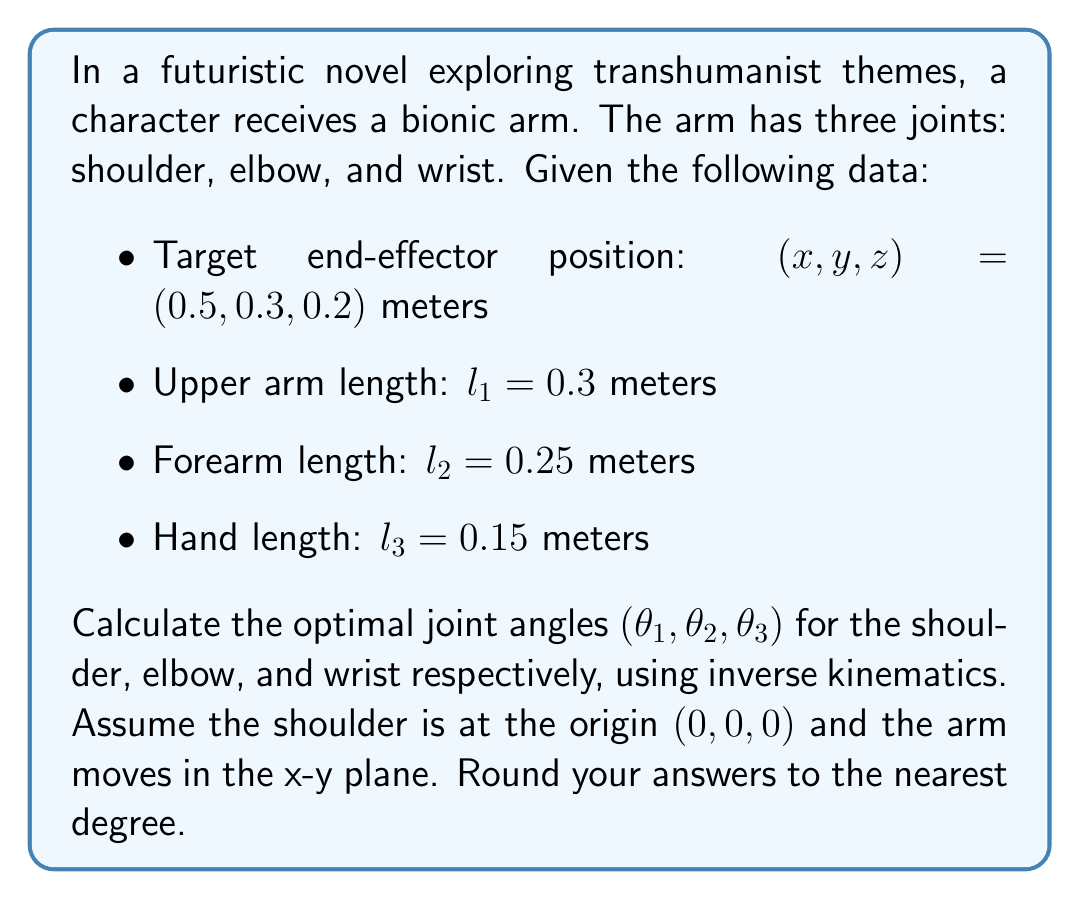Can you answer this question? To solve this inverse kinematics problem, we'll use the following steps:

1) First, we need to calculate the distance from the shoulder to the wrist:
   $$d = \sqrt{(x^2 + y^2)} = \sqrt{0.5^2 + 0.3^2} = 0.5831$$

2) Now, we can use the law of cosines to find the elbow angle $\theta_2$:
   $$\cos(\theta_2) = \frac{l_1^2 + l_2^2 - d^2}{2l_1l_2}$$
   $$\cos(\theta_2) = \frac{0.3^2 + 0.25^2 - 0.5831^2}{2(0.3)(0.25)} = -0.3454$$
   $$\theta_2 = \arccos(-0.3454) = 110.2°$$

3) To find the shoulder angle $\theta_1$, we first calculate two auxiliary angles:
   $$\alpha = \arctan2(y, x) = \arctan2(0.3, 0.5) = 30.96°$$
   $$\beta = \arccos(\frac{l_1^2 + d^2 - l_2^2}{2l_1d}) = \arccos(\frac{0.3^2 + 0.5831^2 - 0.25^2}{2(0.3)(0.5831)}) = 41.41°$$
   Then, $\theta_1 = \alpha - \beta = 30.96° - 41.41° = -10.45°$

4) For the wrist angle $\theta_3$, we need to ensure the hand is horizontal:
   $$\theta_3 = 180° - \theta_1 - \theta_2 = 180° - (-10.45°) - 110.2° = 80.25°$$

5) Rounding to the nearest degree:
   $\theta_1 = -10°$
   $\theta_2 = 110°$
   $\theta_3 = 80°$
Answer: $(\theta_1, \theta_2, \theta_3) = (-10°, 110°, 80°)$ 